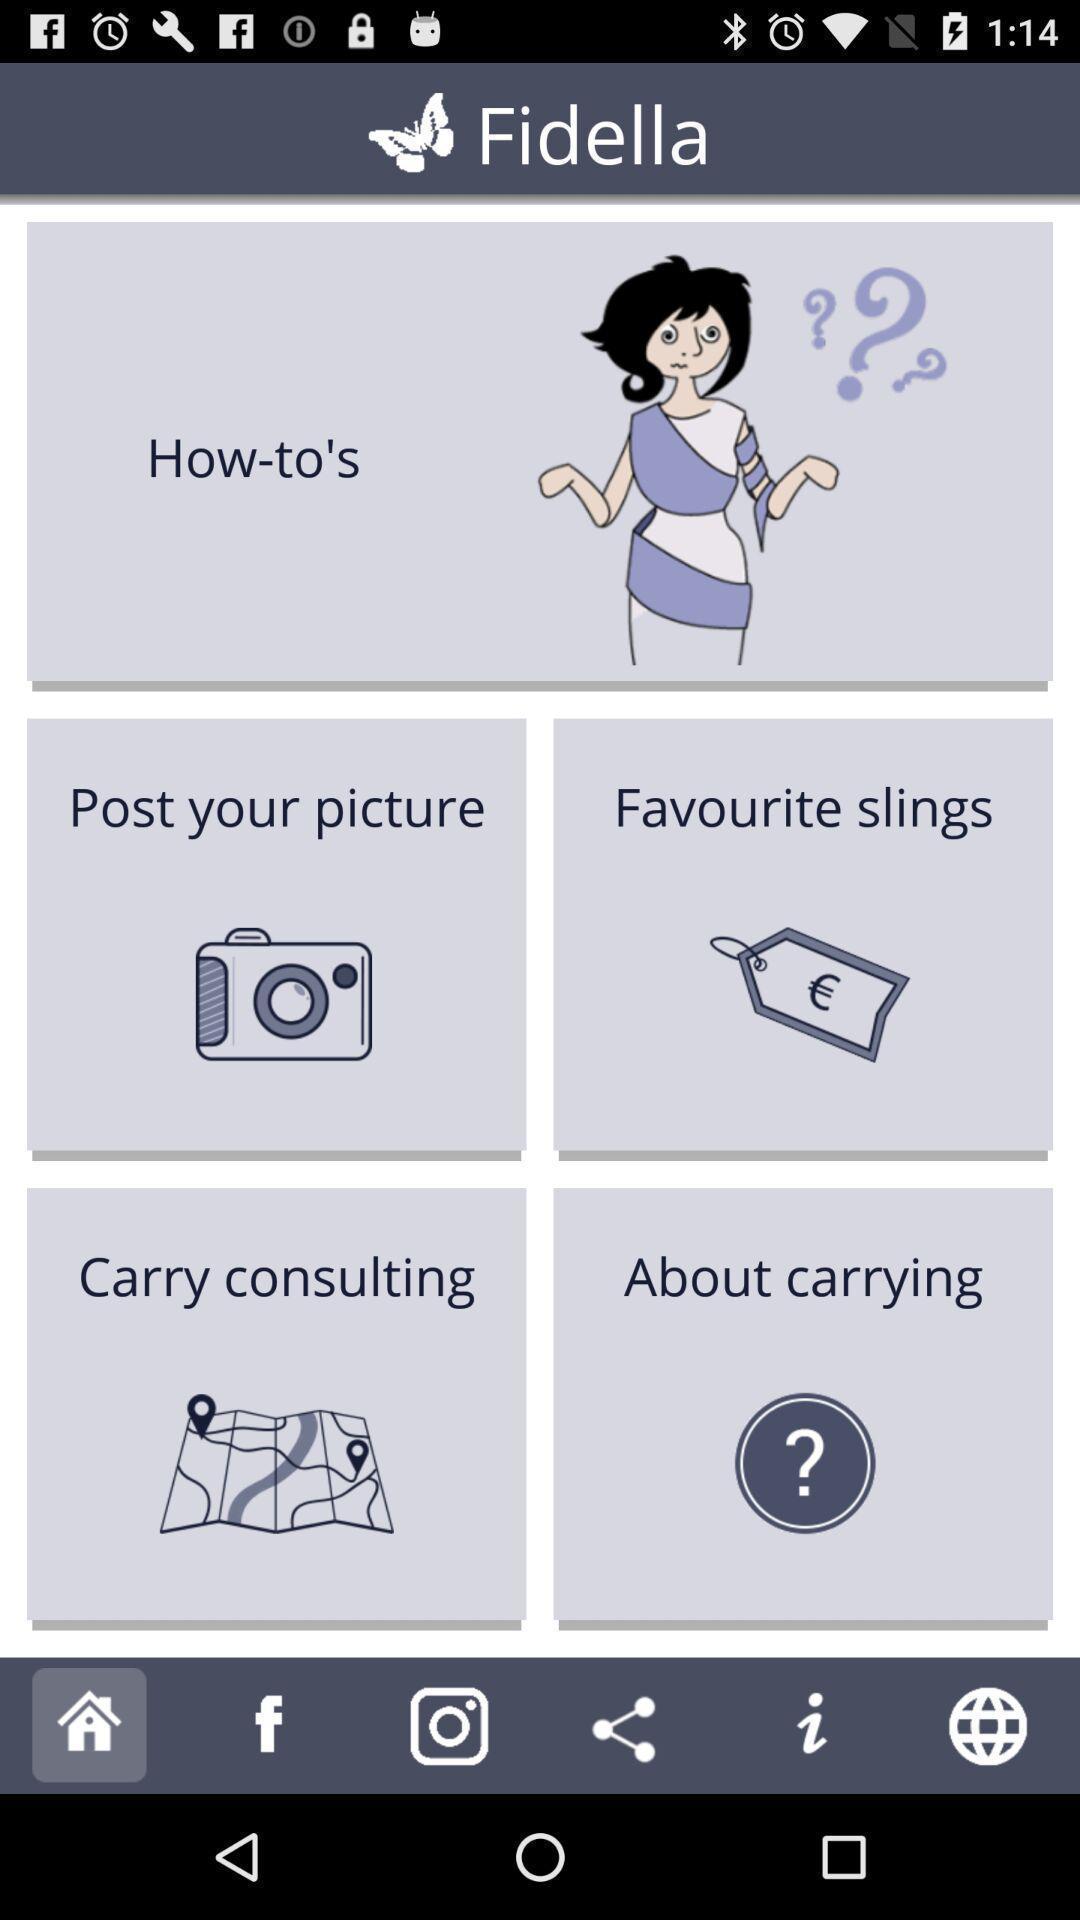Provide a description of this screenshot. Home page with different options. 